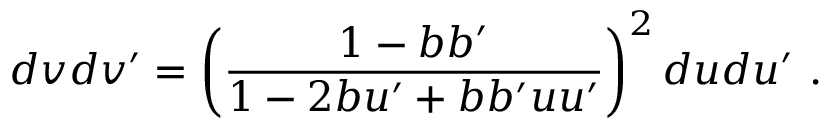<formula> <loc_0><loc_0><loc_500><loc_500>d v d v ^ { \prime } = \left ( \frac { 1 - b b ^ { \prime } } { 1 - 2 b u ^ { \prime } + b b ^ { \prime } u u ^ { \prime } } \right ) ^ { 2 } d u d u ^ { \prime } .</formula> 